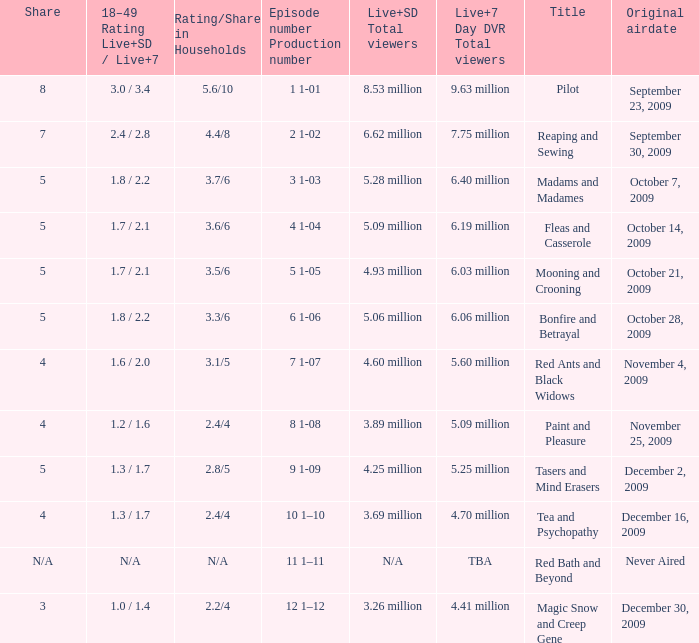When did the fourth episode of the season (4 1-04) first air? October 14, 2009. 